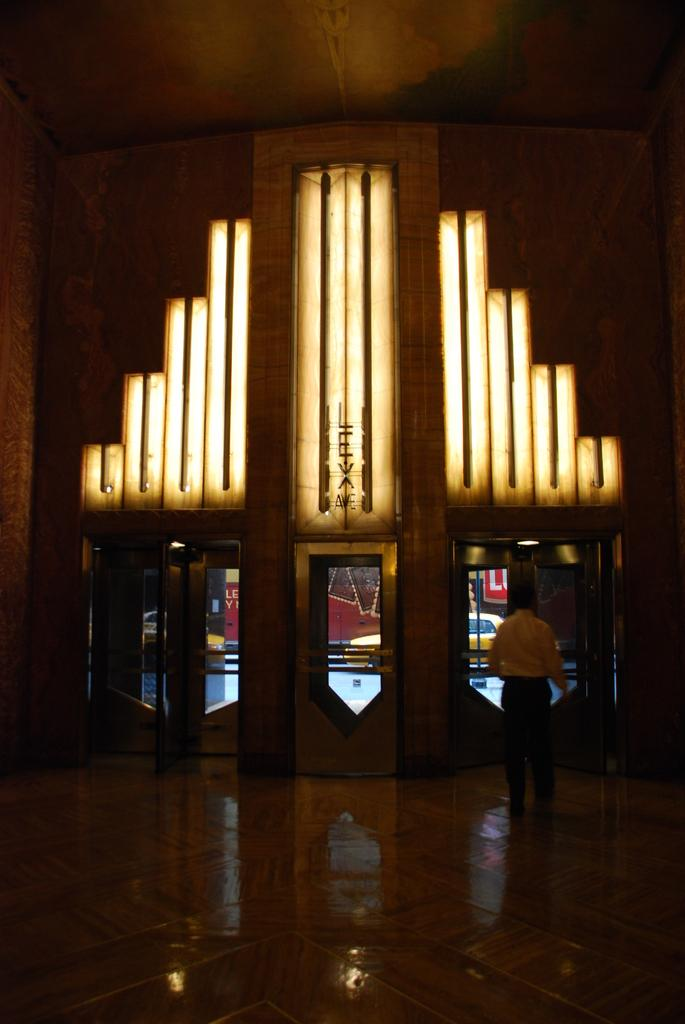What is the main structure in the center of the image? There is a Chrysler building in the center of the image. Can you describe any other elements in the image? There is a man on the right side of the image. What type of bone can be seen in the man's stomach in the image? There is no bone or indication of a stomach in the image; it only features the Chrysler building and a man on the right side. 